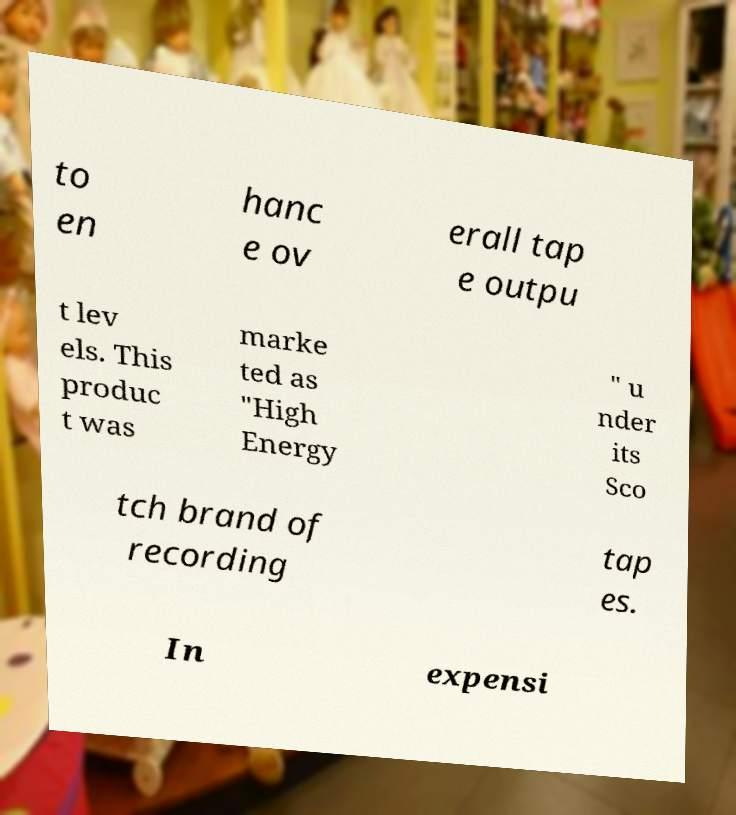Please read and relay the text visible in this image. What does it say? to en hanc e ov erall tap e outpu t lev els. This produc t was marke ted as "High Energy " u nder its Sco tch brand of recording tap es. In expensi 